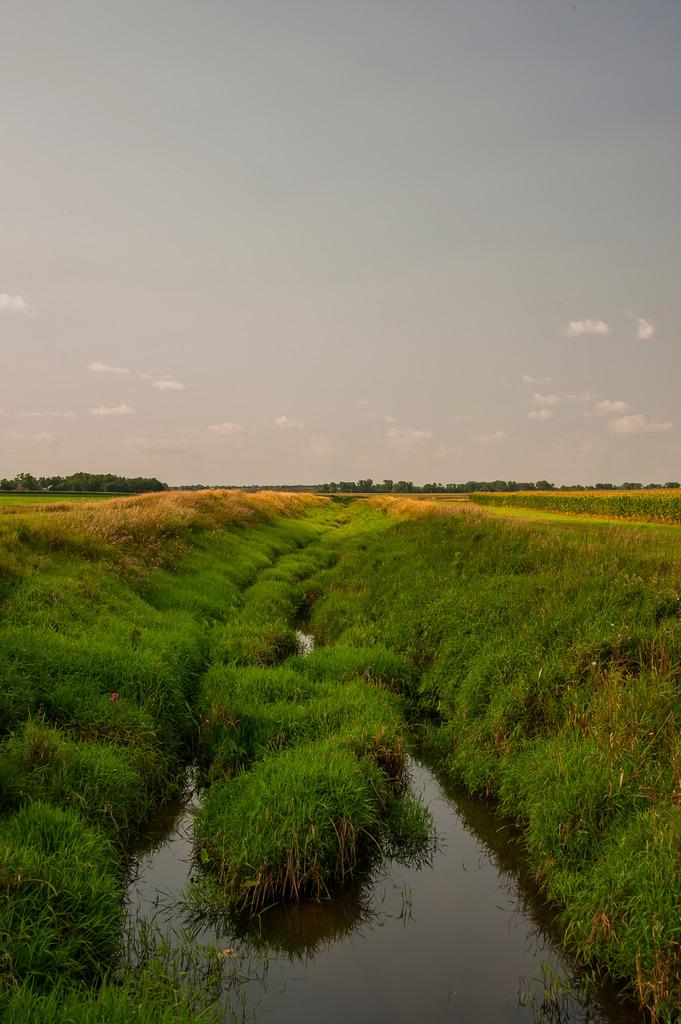What type of terrain is visible in the image? There is an open grass ground in the image. What can be seen at the bottom of the image? There is water visible at the bottom of the image. What is visible in the background of the image? Trees, clouds, and the sky are visible in the background of the image. What type of plate is used to serve the clouds in the image? There is no plate present in the image, and clouds are not being served. 